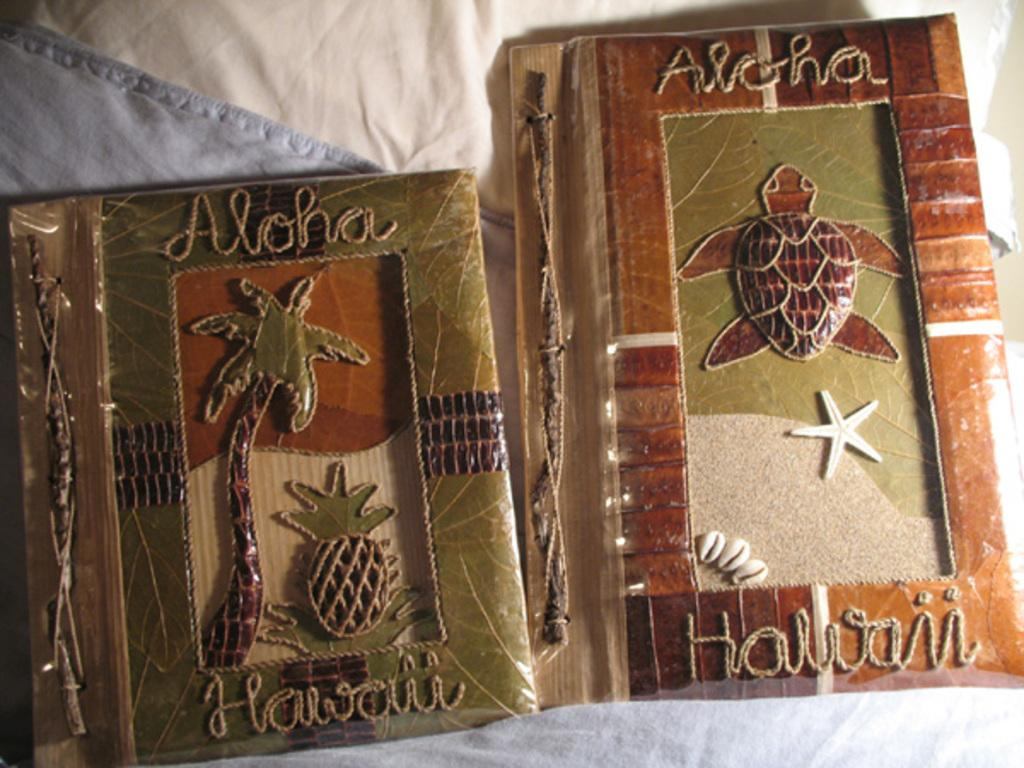<image>
Render a clear and concise summary of the photo. Two decorative art works that says Aloha Hawaii on them. 